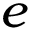Convert formula to latex. <formula><loc_0><loc_0><loc_500><loc_500>e</formula> 